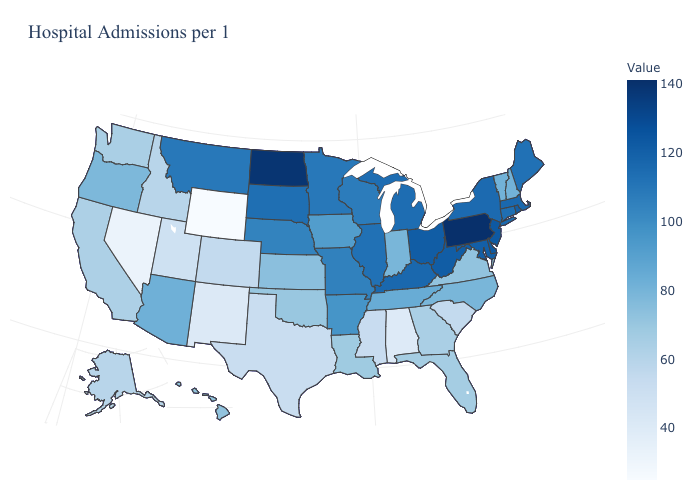Among the states that border Massachusetts , which have the lowest value?
Quick response, please. New Hampshire, Vermont. Which states have the lowest value in the USA?
Quick response, please. Wyoming. Among the states that border Washington , which have the lowest value?
Give a very brief answer. Idaho. 